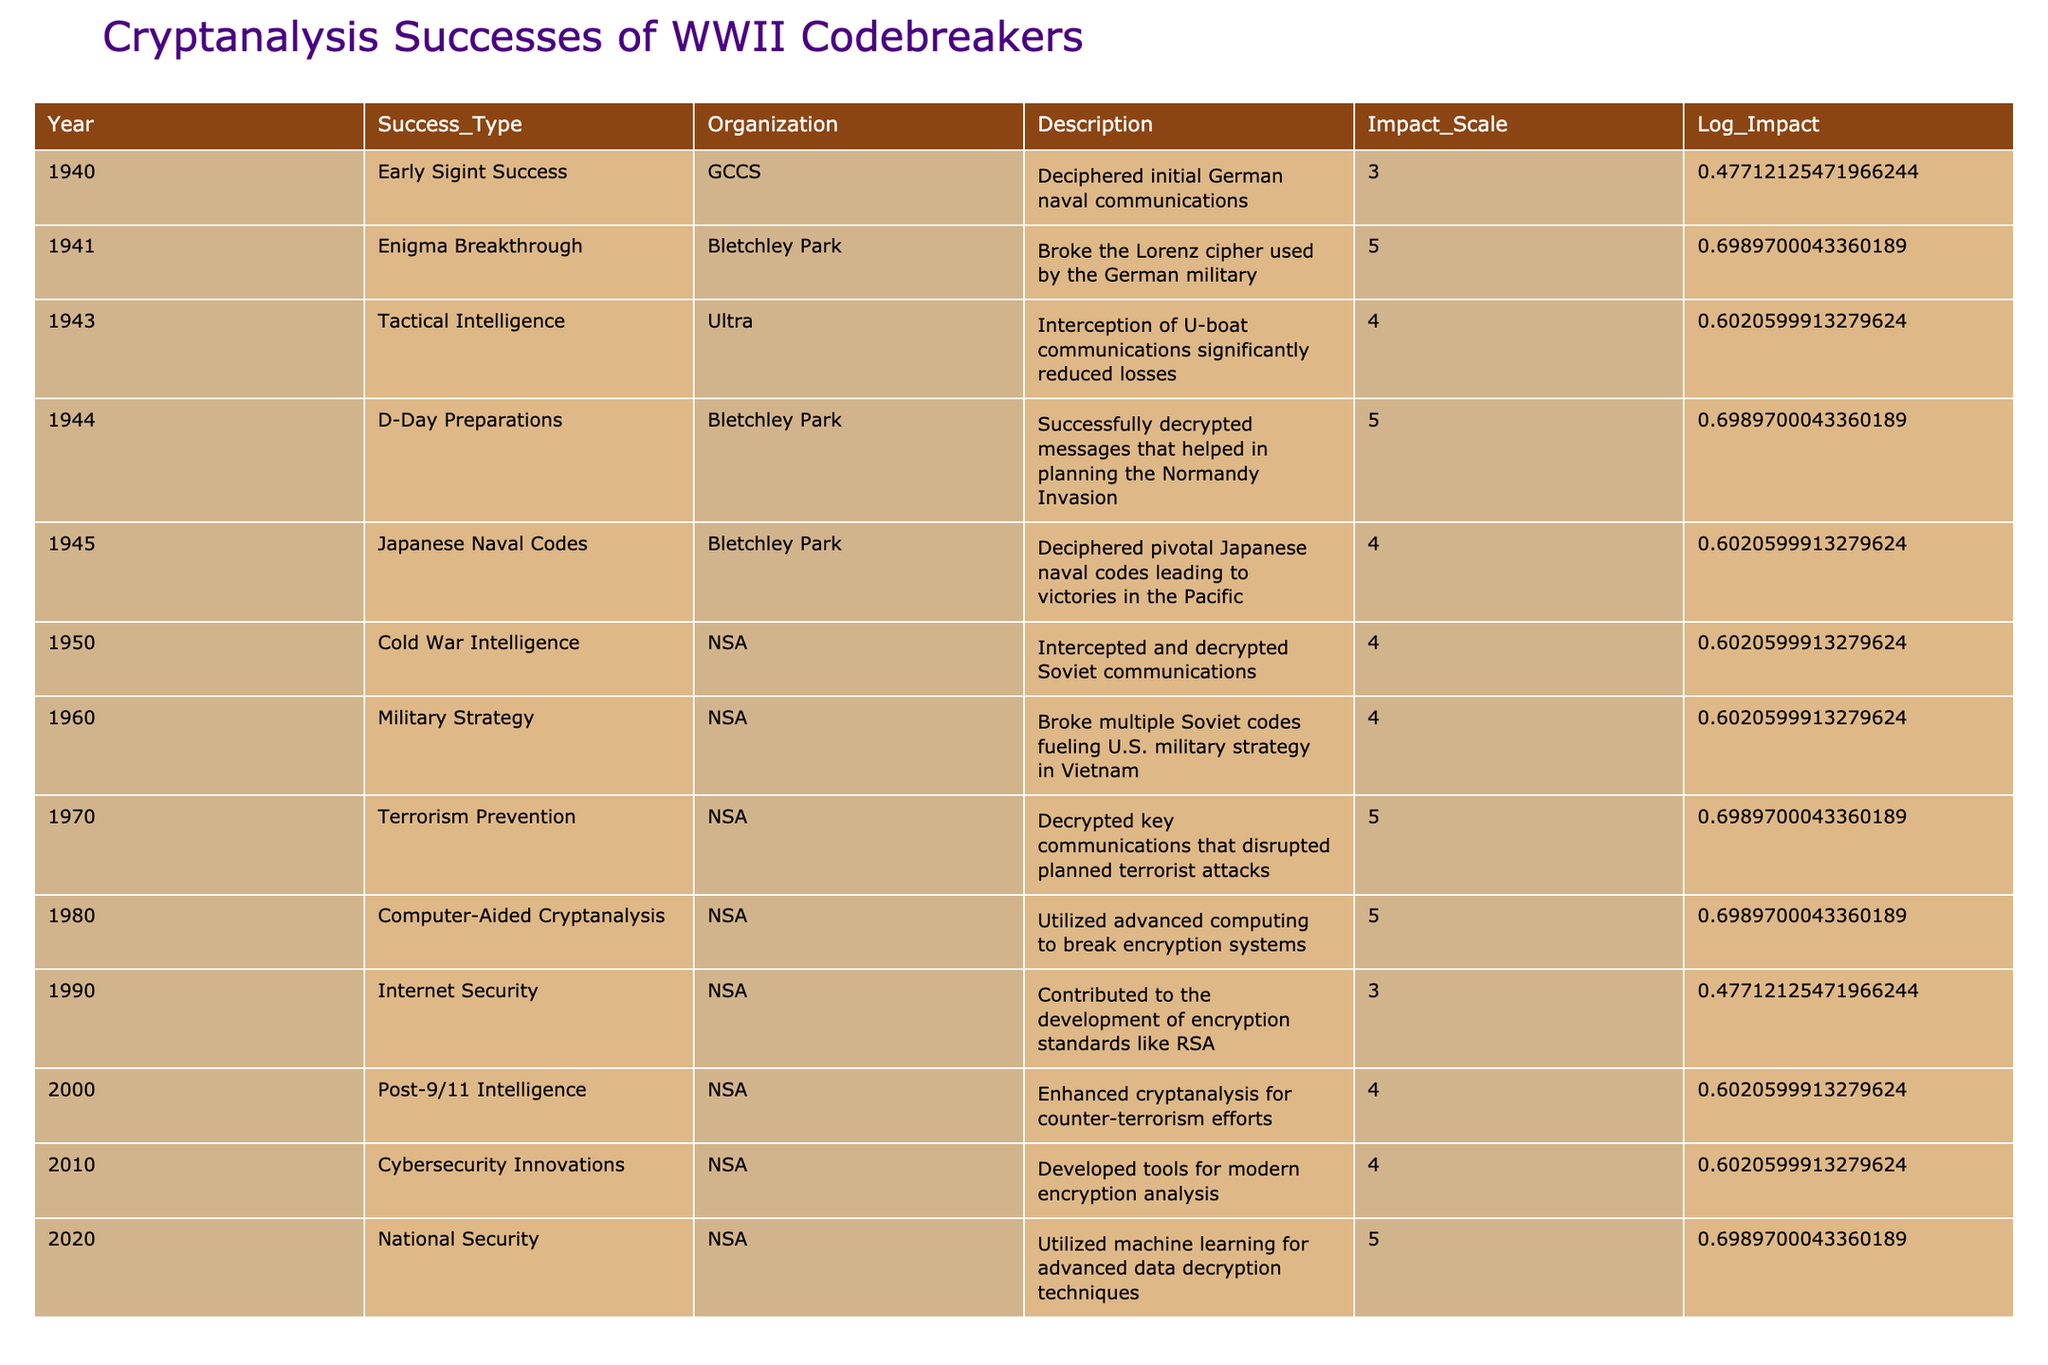What was the highest impact success type recorded in the table? The highest impact recorded in the table is 5. Looking at the "Impact_Scale" column, the success types that received a score of 5 are: "Enigma Breakthrough," "D-Day Preparations," "Terrorism Prevention," "Computer-Aided Cryptanalysis," and "National Security." However, these are all from different years, so there isn't a single entry that holds this distinction over another.
Answer: 5 Which organization had the most entries in the table? The "NSA" organization appears multiple times in the table spanning different years. Counting the entries, "NSA" appears four times, while "Bletchley Park" and "Ultra" each have three. This makes "NSA" the organization with the most entries.
Answer: NSA What year had significant contributions to Internet Security in the context of cryptanalysis? The year 1990 is specifically noted for "Internet Security" where contributions were made to the development of encryption standards like RSA. This is an observable fact within the table data that can be directly checked.
Answer: 1990 How many total successes listed in the table had an impact scale of at least 4? A quick glance shows that the impact scale of at least 4 includes the following successes: "Enigma Breakthrough," "Tactical Intelligence," "D-Day Preparations," "Japanese Naval Codes," "Cold War Intelligence," "Military Strategy," "Terrorism Prevention," "Computer-Aided Cryptanalysis," "Post-9/11 Intelligence," "Cybersecurity Innovations," and "National Security." To count, there are 11 entries that meet this criteria.
Answer: 11 Did Bletchley Park have any contributions after 1945? According to the table, Bletchley Park's last listed success is in 1945 regarding Japanese Naval Codes. There are no later entries for Bletchley Park in the subsequent years, indicating that there were no contributions logged after 1945.
Answer: No 